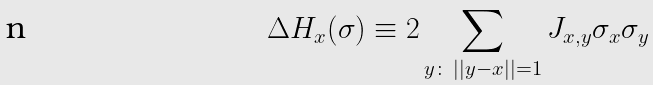<formula> <loc_0><loc_0><loc_500><loc_500>\Delta H _ { x } ( \sigma ) \equiv 2 \sum _ { y \colon \, | | y - x | | = 1 } J _ { x , y } \sigma _ { x } \sigma _ { y } \</formula> 